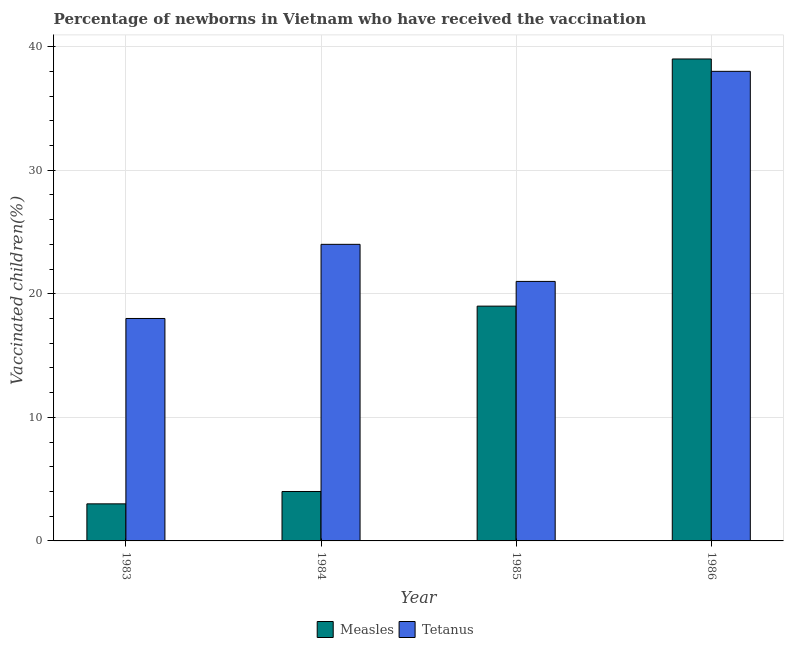How many groups of bars are there?
Your response must be concise. 4. Are the number of bars per tick equal to the number of legend labels?
Offer a very short reply. Yes. Are the number of bars on each tick of the X-axis equal?
Offer a terse response. Yes. How many bars are there on the 1st tick from the left?
Your answer should be very brief. 2. How many bars are there on the 1st tick from the right?
Give a very brief answer. 2. What is the label of the 2nd group of bars from the left?
Provide a succinct answer. 1984. What is the percentage of newborns who received vaccination for measles in 1983?
Offer a very short reply. 3. Across all years, what is the maximum percentage of newborns who received vaccination for measles?
Offer a terse response. 39. Across all years, what is the minimum percentage of newborns who received vaccination for measles?
Ensure brevity in your answer.  3. In which year was the percentage of newborns who received vaccination for tetanus minimum?
Your response must be concise. 1983. What is the total percentage of newborns who received vaccination for measles in the graph?
Make the answer very short. 65. What is the difference between the percentage of newborns who received vaccination for tetanus in 1983 and that in 1985?
Keep it short and to the point. -3. What is the difference between the percentage of newborns who received vaccination for measles in 1986 and the percentage of newborns who received vaccination for tetanus in 1985?
Offer a very short reply. 20. What is the average percentage of newborns who received vaccination for measles per year?
Keep it short and to the point. 16.25. What is the ratio of the percentage of newborns who received vaccination for tetanus in 1983 to that in 1985?
Your response must be concise. 0.86. Is the percentage of newborns who received vaccination for measles in 1983 less than that in 1985?
Your answer should be very brief. Yes. What is the difference between the highest and the second highest percentage of newborns who received vaccination for tetanus?
Your answer should be very brief. 14. What is the difference between the highest and the lowest percentage of newborns who received vaccination for measles?
Your answer should be compact. 36. In how many years, is the percentage of newborns who received vaccination for tetanus greater than the average percentage of newborns who received vaccination for tetanus taken over all years?
Your answer should be very brief. 1. What does the 1st bar from the left in 1984 represents?
Your answer should be compact. Measles. What does the 1st bar from the right in 1986 represents?
Make the answer very short. Tetanus. Are all the bars in the graph horizontal?
Offer a very short reply. No. How many years are there in the graph?
Provide a short and direct response. 4. Does the graph contain grids?
Provide a succinct answer. Yes. Where does the legend appear in the graph?
Ensure brevity in your answer.  Bottom center. What is the title of the graph?
Your answer should be very brief. Percentage of newborns in Vietnam who have received the vaccination. Does "Female" appear as one of the legend labels in the graph?
Give a very brief answer. No. What is the label or title of the X-axis?
Your response must be concise. Year. What is the label or title of the Y-axis?
Your answer should be very brief. Vaccinated children(%)
. What is the Vaccinated children(%)
 in Measles in 1983?
Make the answer very short. 3. What is the Vaccinated children(%)
 in Measles in 1984?
Your response must be concise. 4. What is the Vaccinated children(%)
 in Tetanus in 1985?
Provide a short and direct response. 21. What is the Vaccinated children(%)
 in Measles in 1986?
Provide a short and direct response. 39. Across all years, what is the maximum Vaccinated children(%)
 in Measles?
Provide a succinct answer. 39. Across all years, what is the maximum Vaccinated children(%)
 in Tetanus?
Keep it short and to the point. 38. Across all years, what is the minimum Vaccinated children(%)
 of Measles?
Your answer should be compact. 3. Across all years, what is the minimum Vaccinated children(%)
 of Tetanus?
Offer a terse response. 18. What is the total Vaccinated children(%)
 in Measles in the graph?
Ensure brevity in your answer.  65. What is the total Vaccinated children(%)
 of Tetanus in the graph?
Provide a short and direct response. 101. What is the difference between the Vaccinated children(%)
 of Measles in 1983 and that in 1984?
Provide a short and direct response. -1. What is the difference between the Vaccinated children(%)
 in Tetanus in 1983 and that in 1984?
Give a very brief answer. -6. What is the difference between the Vaccinated children(%)
 in Measles in 1983 and that in 1985?
Your answer should be very brief. -16. What is the difference between the Vaccinated children(%)
 in Tetanus in 1983 and that in 1985?
Your answer should be compact. -3. What is the difference between the Vaccinated children(%)
 in Measles in 1983 and that in 1986?
Provide a short and direct response. -36. What is the difference between the Vaccinated children(%)
 of Measles in 1984 and that in 1986?
Give a very brief answer. -35. What is the difference between the Vaccinated children(%)
 in Tetanus in 1984 and that in 1986?
Provide a short and direct response. -14. What is the difference between the Vaccinated children(%)
 of Measles in 1985 and that in 1986?
Provide a short and direct response. -20. What is the difference between the Vaccinated children(%)
 in Measles in 1983 and the Vaccinated children(%)
 in Tetanus in 1984?
Provide a short and direct response. -21. What is the difference between the Vaccinated children(%)
 of Measles in 1983 and the Vaccinated children(%)
 of Tetanus in 1986?
Provide a short and direct response. -35. What is the difference between the Vaccinated children(%)
 in Measles in 1984 and the Vaccinated children(%)
 in Tetanus in 1985?
Make the answer very short. -17. What is the difference between the Vaccinated children(%)
 in Measles in 1984 and the Vaccinated children(%)
 in Tetanus in 1986?
Your answer should be very brief. -34. What is the average Vaccinated children(%)
 of Measles per year?
Your answer should be very brief. 16.25. What is the average Vaccinated children(%)
 of Tetanus per year?
Give a very brief answer. 25.25. In the year 1985, what is the difference between the Vaccinated children(%)
 in Measles and Vaccinated children(%)
 in Tetanus?
Provide a succinct answer. -2. What is the ratio of the Vaccinated children(%)
 in Tetanus in 1983 to that in 1984?
Ensure brevity in your answer.  0.75. What is the ratio of the Vaccinated children(%)
 in Measles in 1983 to that in 1985?
Your answer should be very brief. 0.16. What is the ratio of the Vaccinated children(%)
 in Measles in 1983 to that in 1986?
Provide a short and direct response. 0.08. What is the ratio of the Vaccinated children(%)
 in Tetanus in 1983 to that in 1986?
Keep it short and to the point. 0.47. What is the ratio of the Vaccinated children(%)
 in Measles in 1984 to that in 1985?
Provide a succinct answer. 0.21. What is the ratio of the Vaccinated children(%)
 of Tetanus in 1984 to that in 1985?
Your answer should be very brief. 1.14. What is the ratio of the Vaccinated children(%)
 of Measles in 1984 to that in 1986?
Make the answer very short. 0.1. What is the ratio of the Vaccinated children(%)
 in Tetanus in 1984 to that in 1986?
Your response must be concise. 0.63. What is the ratio of the Vaccinated children(%)
 of Measles in 1985 to that in 1986?
Provide a succinct answer. 0.49. What is the ratio of the Vaccinated children(%)
 of Tetanus in 1985 to that in 1986?
Provide a succinct answer. 0.55. What is the difference between the highest and the lowest Vaccinated children(%)
 in Measles?
Give a very brief answer. 36. 